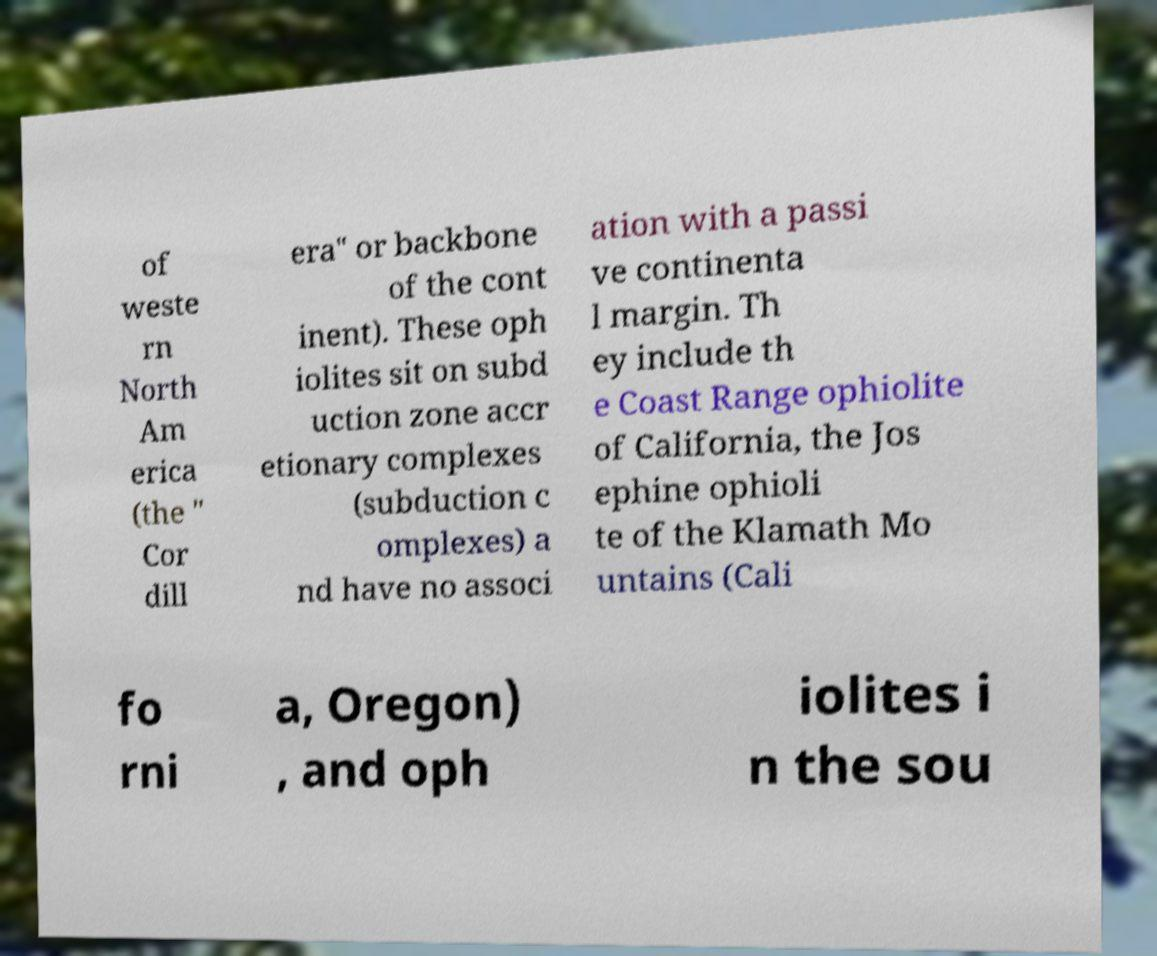Can you read and provide the text displayed in the image?This photo seems to have some interesting text. Can you extract and type it out for me? of weste rn North Am erica (the " Cor dill era" or backbone of the cont inent). These oph iolites sit on subd uction zone accr etionary complexes (subduction c omplexes) a nd have no associ ation with a passi ve continenta l margin. Th ey include th e Coast Range ophiolite of California, the Jos ephine ophioli te of the Klamath Mo untains (Cali fo rni a, Oregon) , and oph iolites i n the sou 